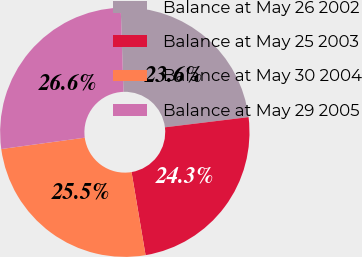Convert chart. <chart><loc_0><loc_0><loc_500><loc_500><pie_chart><fcel>Balance at May 26 2002<fcel>Balance at May 25 2003<fcel>Balance at May 30 2004<fcel>Balance at May 29 2005<nl><fcel>23.59%<fcel>24.27%<fcel>25.51%<fcel>26.63%<nl></chart> 